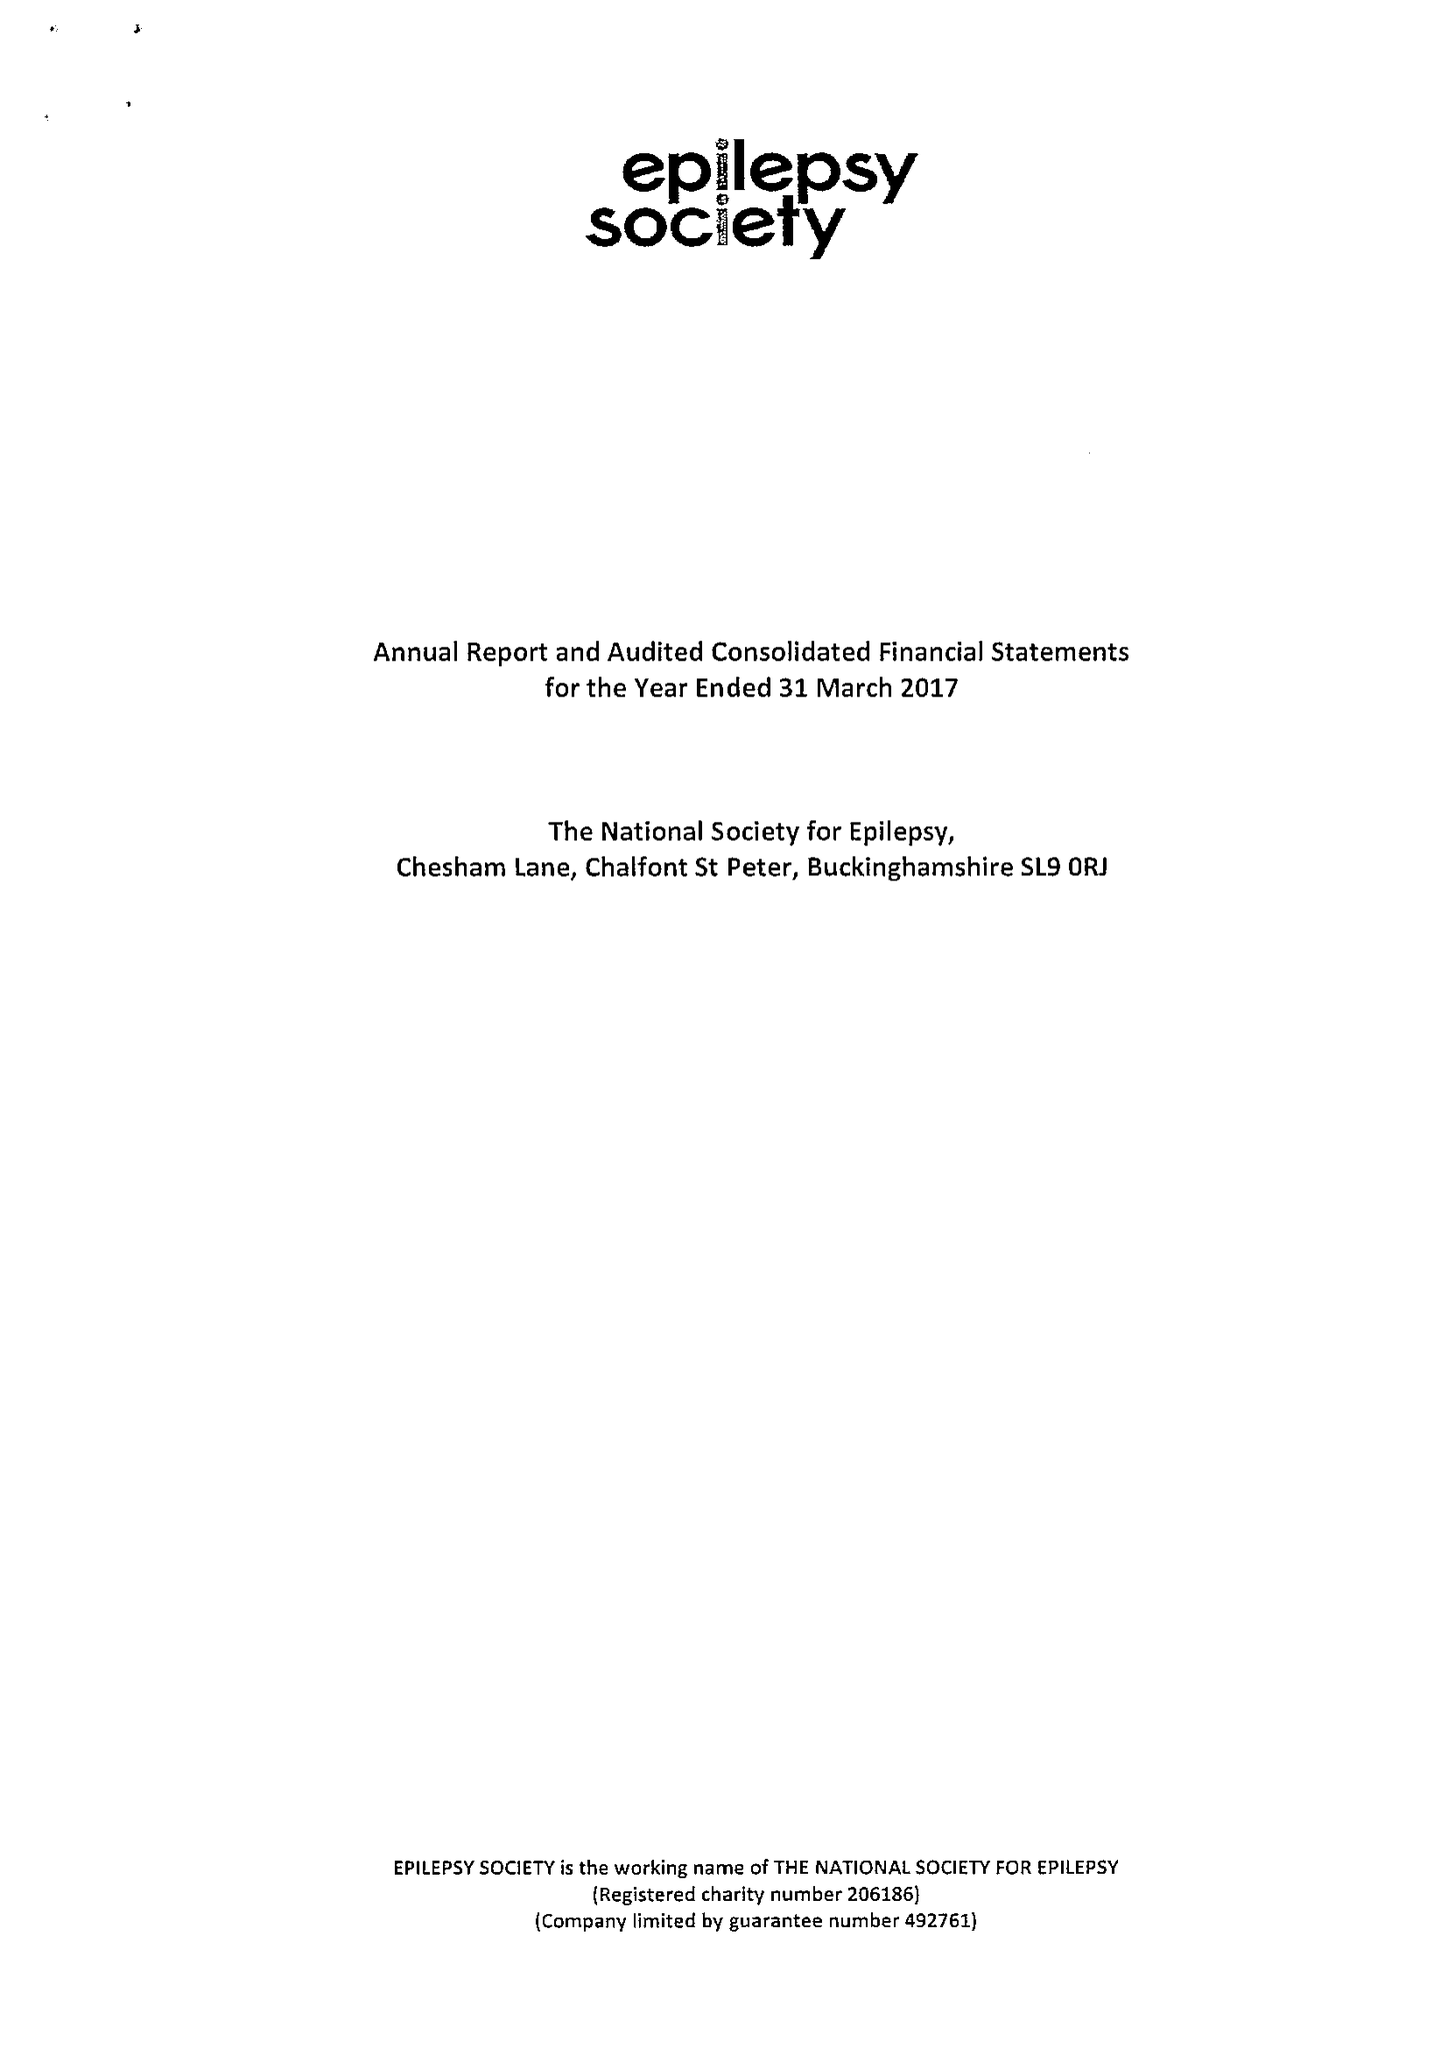What is the value for the report_date?
Answer the question using a single word or phrase. 2017-03-31 